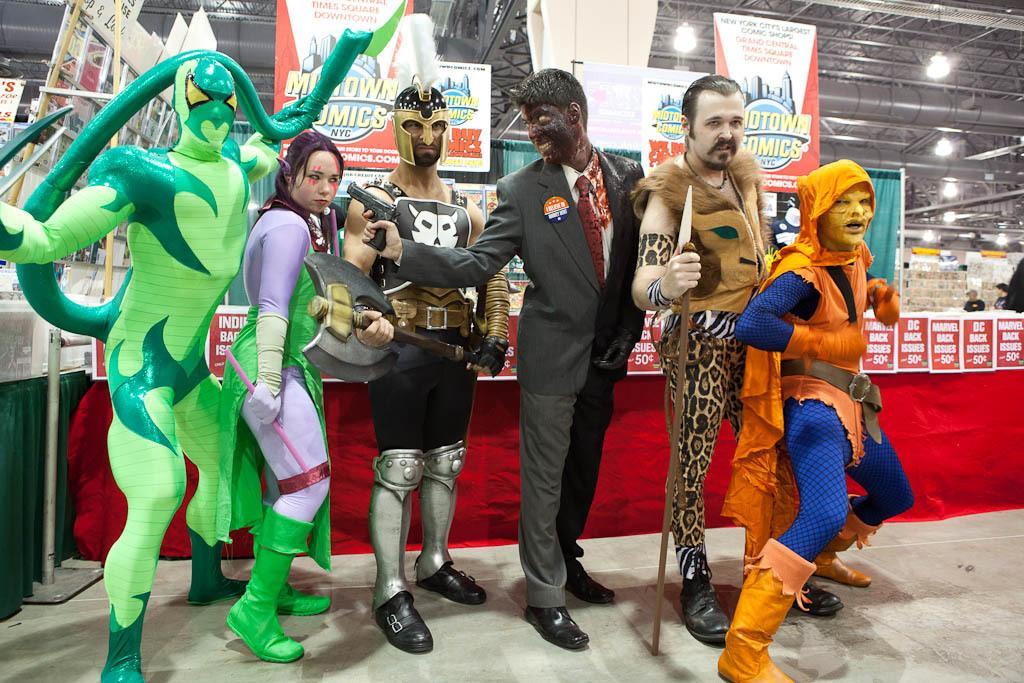How would you summarize this image in a sentence or two? In this image we can see few persons are wearing some different kind of clothes are standing on the floor. In the back of them there are many boards and banners attached to the wall. 